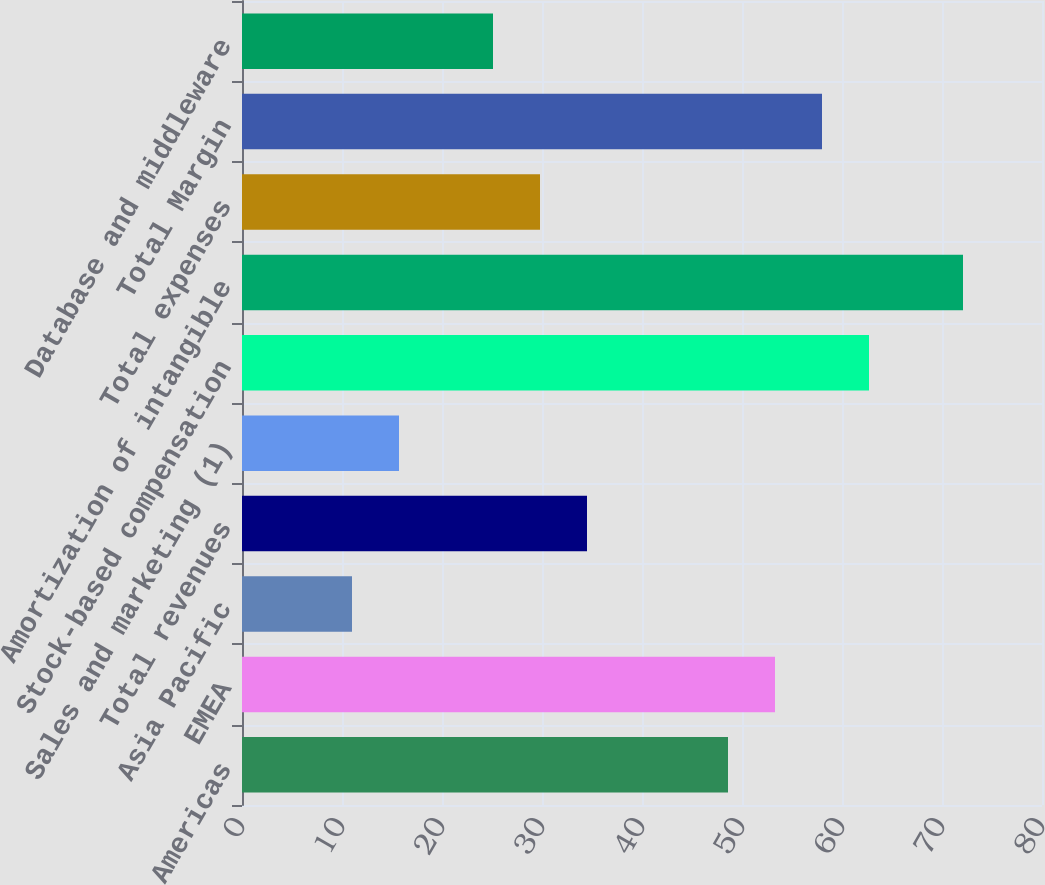<chart> <loc_0><loc_0><loc_500><loc_500><bar_chart><fcel>Americas<fcel>EMEA<fcel>Asia Pacific<fcel>Total revenues<fcel>Sales and marketing (1)<fcel>Stock-based compensation<fcel>Amortization of intangible<fcel>Total expenses<fcel>Total Margin<fcel>Database and middleware<nl><fcel>48.6<fcel>53.3<fcel>11<fcel>34.5<fcel>15.7<fcel>62.7<fcel>72.1<fcel>29.8<fcel>58<fcel>25.1<nl></chart> 